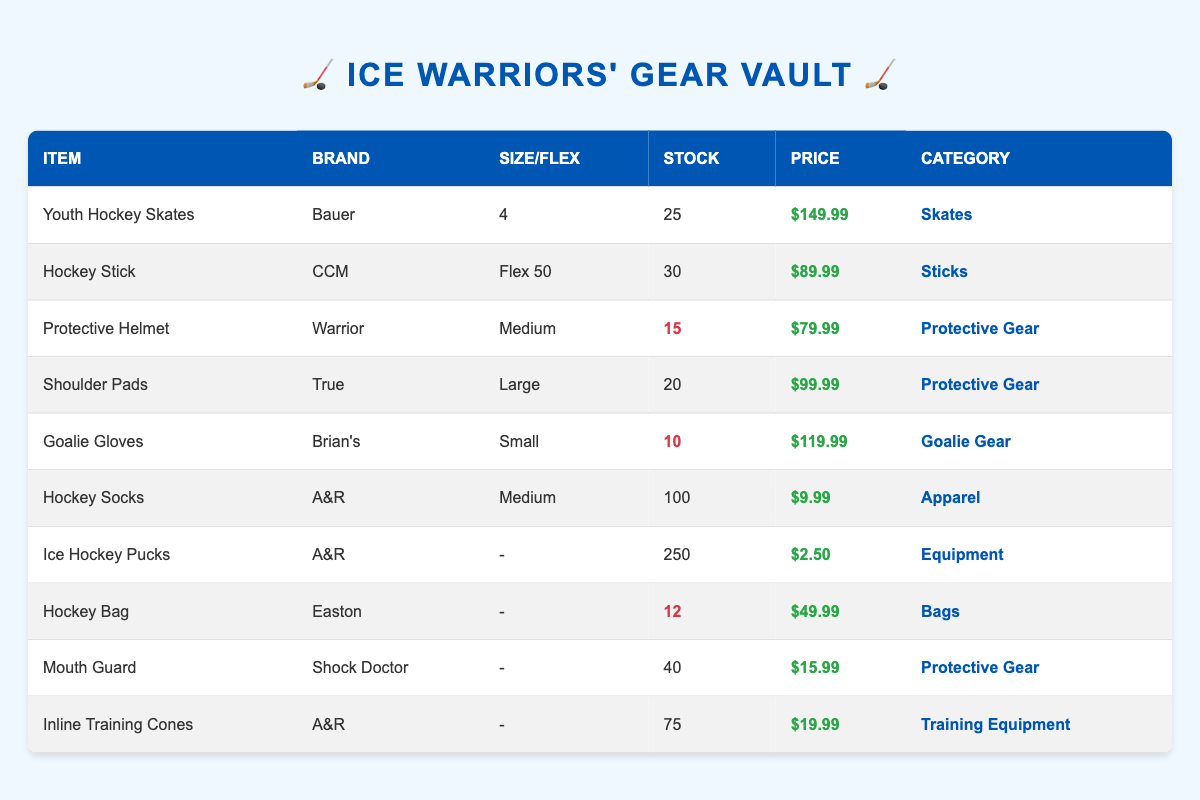What is the price of the Youth Hockey Skates? By locating the row for "Youth Hockey Skates" in the table, I can see the price listed is $149.99.
Answer: $149.99 How many Goalie Gloves are in stock? The "Goalie Gloves" entry shows that there are 10 in stock.
Answer: 10 Which item has the highest stock level? Looking through the stock quantities, "Ice Hockey Pucks" has the highest quantity at 250.
Answer: Ice Hockey Pucks How many total Protective Gear items are in stock? By adding the stock of Protective Gear items: 15 (Helmet) + 20 (Shoulder Pads) + 10 (Goalie Gloves) + 40 (Mouth Guard) = 85.
Answer: 85 Is there a protective gear item that has less than 20 in stock? Yes, the "Protective Helmet" with 15 and the "Goalie Gloves" with 10 are both below 20.
Answer: Yes What is the average price of the training equipment listed? The only training equipment listed is the "Inline Training Cones," priced at $19.99. Thus, the average is simply $19.99.
Answer: $19.99 How many different categories of items are there? Counting the unique categories from the table shows there are five: Skates, Sticks, Protective Gear, Goalie Gear, Apparel, Equipment, Bags, and Training Equipment, resulting in a total of 8.
Answer: 8 Which brand has the least number of items in stock? Analyzing the stock levels, "Brian’s" has the least with 10 Goalie Gloves, while "Easton" has 12 Hockey Bags; therefore, the least is 10.
Answer: Brian's If a team buys 5 Hockey Socks, how many would be left in stock? Starting with 100 Hockey Socks and subtracting 5 gives: 100 - 5 = 95 remaining in stock.
Answer: 95 